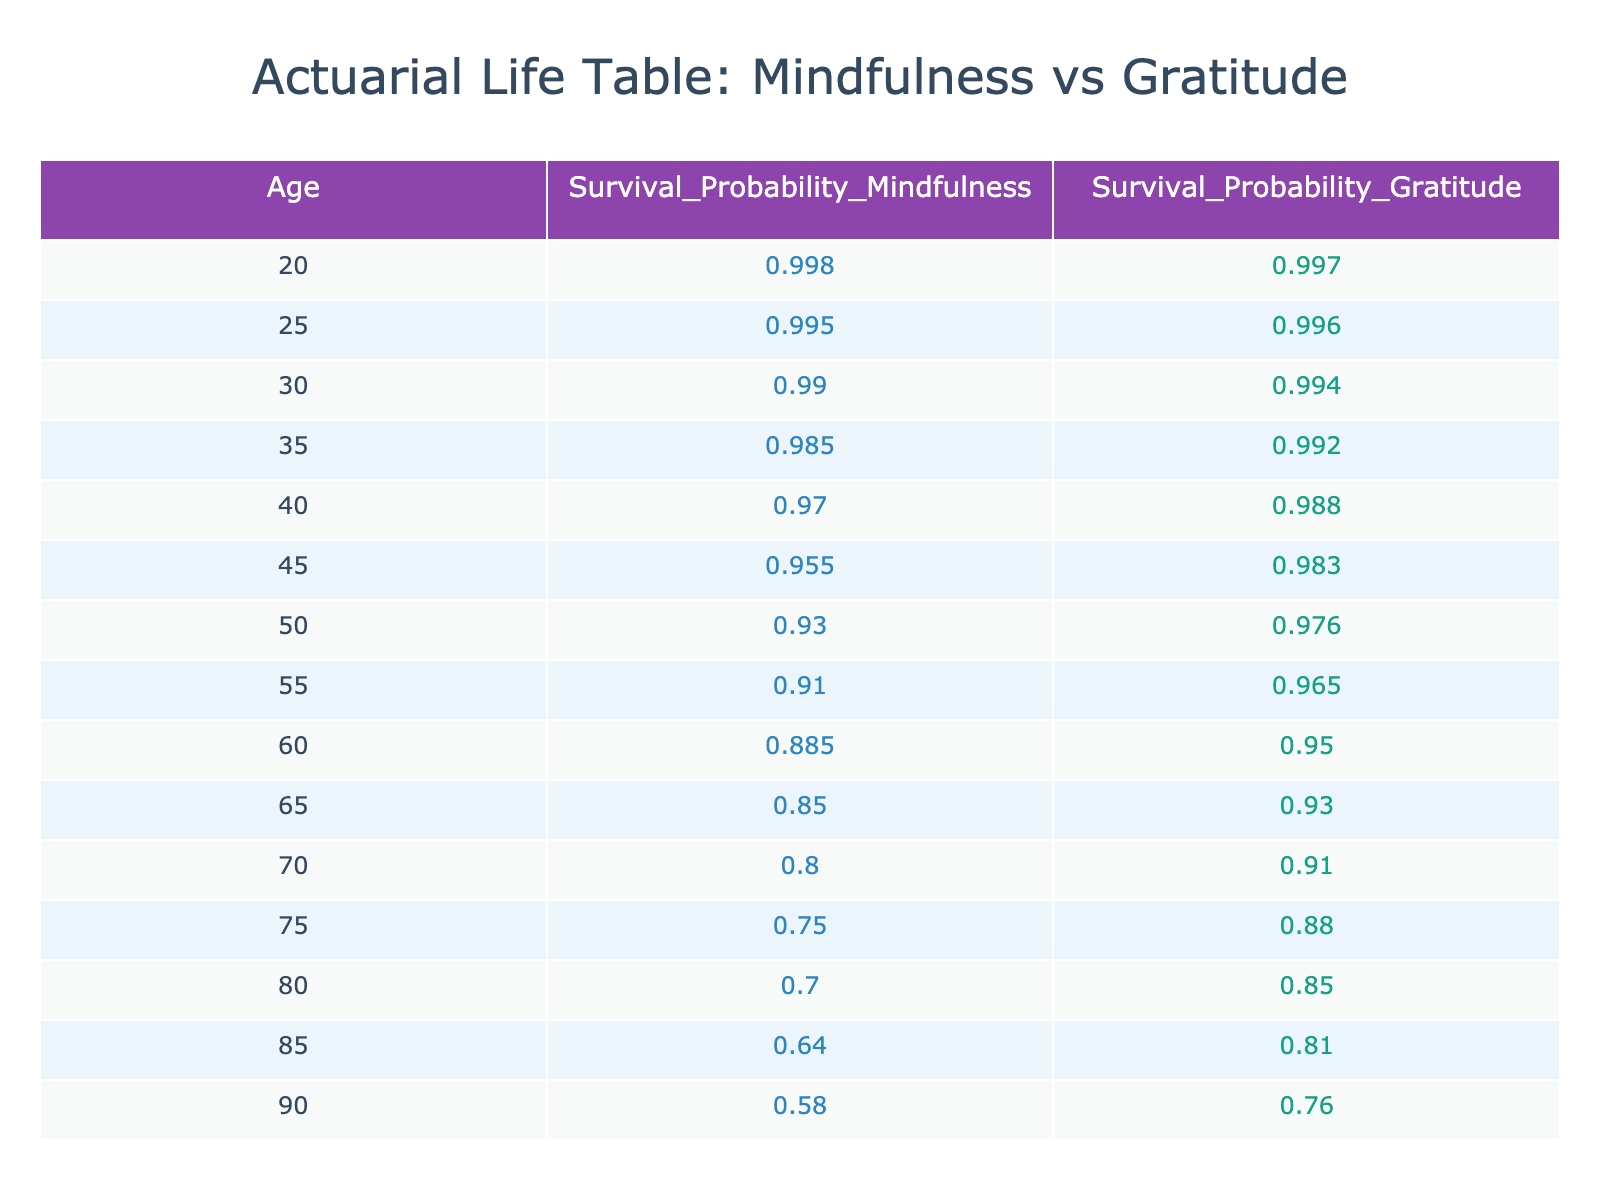What is the survival probability for individuals practicing mindfulness at age 60? The table indicates the survival probability for individuals practicing mindfulness at age 60 is found in the corresponding row for age 60 under the "Survival_Probability_Mindfulness" column. That value is 0.885.
Answer: 0.885 What is the survival probability for individuals practicing gratitude at age 45? Looking at the row for age 45 in the table, the survival probability for individuals practicing gratitude is specified in the "Survival_Probability_Gratitude" column, which is 0.983.
Answer: 0.983 What is the difference in survival probabilities between mindfulness and gratitude practices at age 70? To find the difference, we look at the values for age 70. The survival probability for mindfulness is 0.800 and for gratitude is 0.910. The difference is calculated as 0.910 - 0.800 = 0.110.
Answer: 0.110 Are individuals practicing mindfulness more likely to survive to age 80 than those practicing gratitude? At age 80, the survival probability for mindfulness is 0.700, while for gratitude it is 0.850. Since 0.700 is less than 0.850, the statement is false.
Answer: No What is the average survival probability for individuals practicing gratitude between the ages of 50 and 70? The relevant survival probabilities for gratitude between ages 50 and 70 are: 0.976 (age 50), 0.965 (age 55), 0.950 (age 60), 0.930 (age 65), and 0.910 (age 70). First, summing these values gives 0.976 + 0.965 + 0.950 + 0.930 + 0.910 = 4.731. Then, dividing by the number of values (5) yields an average of 4.731 / 5 = 0.9462, which can be rounded to 0.946.
Answer: 0.946 Is the survival probability higher for mindfulness at age 30 than for gratitude at age 35? The survival probability for mindfulness at age 30 is 0.990, and for gratitude at age 35 it is 0.992. Since 0.990 is less than 0.992, the statement is false.
Answer: No What is the lowest survival probability recorded for individuals practicing gratitude, and at what age does it occur? To find this, we check each age row for the "Survival_Probability_Gratitude". The lowest value in the table is 0.760, which occurs at age 90.
Answer: 0.760 at age 90 What is the sum of the survival probabilities for individuals practicing mindfulness between ages 20 and 50? The survival probabilities for mindfulness in that range are: 0.998 (age 20), 0.995 (age 25), 0.990 (age 30), 0.985 (age 35), 0.970 (age 40), and 0.955 (age 45), and 0.930 (age 50). Summing these gives 0.998 + 0.995 + 0.990 + 0.985 + 0.970 + 0.955 + 0.930 = 6.823.
Answer: 6.823 